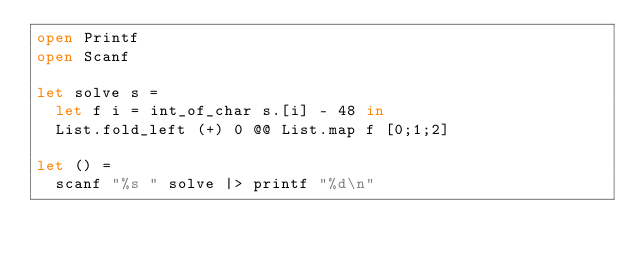<code> <loc_0><loc_0><loc_500><loc_500><_OCaml_>open Printf
open Scanf

let solve s =
  let f i = int_of_char s.[i] - 48 in
  List.fold_left (+) 0 @@ List.map f [0;1;2]

let () =
  scanf "%s " solve |> printf "%d\n"
</code> 